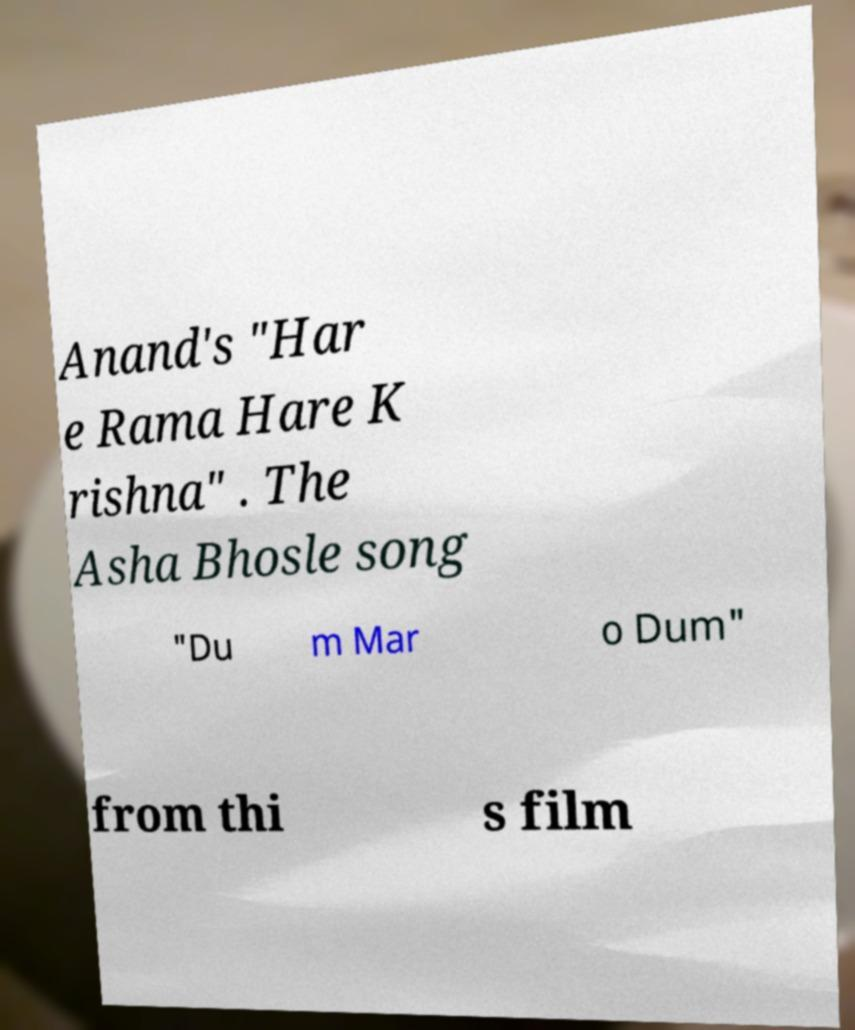What messages or text are displayed in this image? I need them in a readable, typed format. Anand's "Har e Rama Hare K rishna" . The Asha Bhosle song "Du m Mar o Dum" from thi s film 